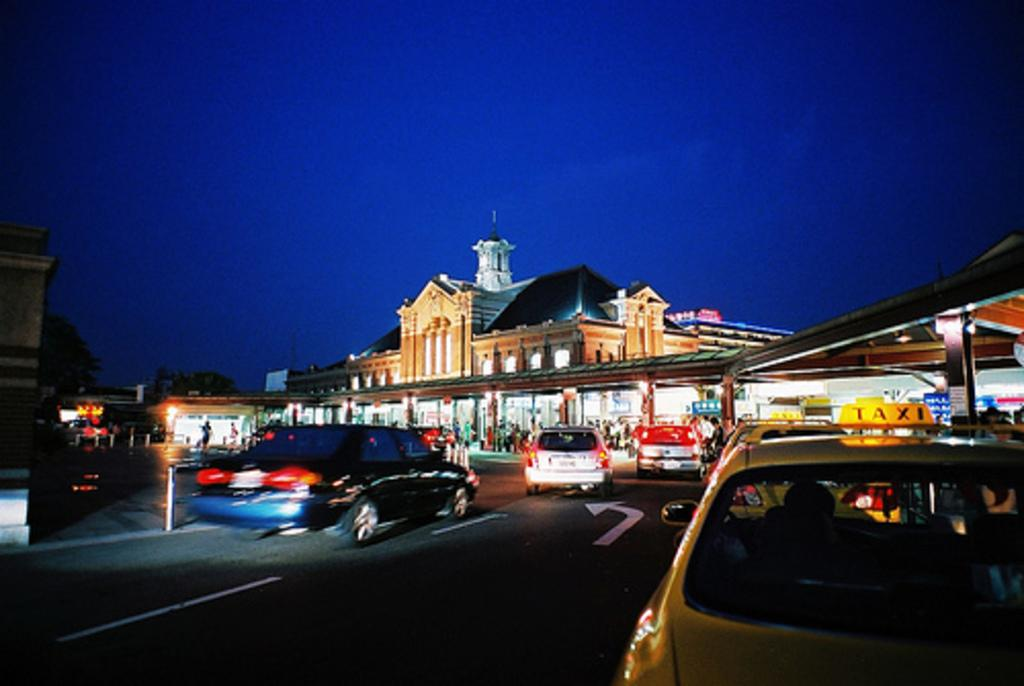<image>
Present a compact description of the photo's key features. A yellow car with a lighted sign atop reading "TAXI" is amongst many other cars on the road. 